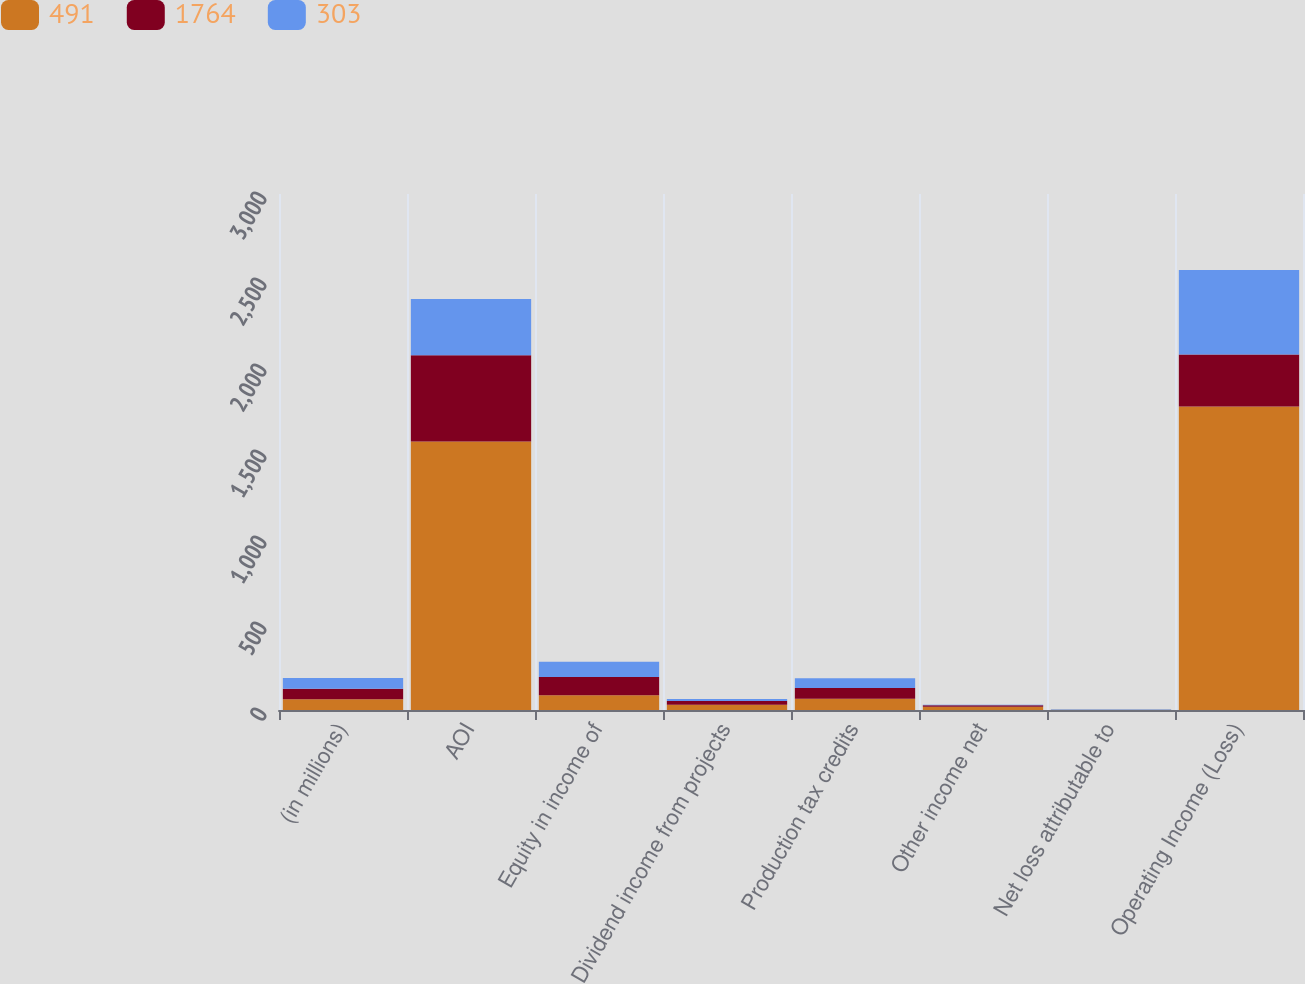<chart> <loc_0><loc_0><loc_500><loc_500><stacked_bar_chart><ecel><fcel>(in millions)<fcel>AOI<fcel>Equity in income of<fcel>Dividend income from projects<fcel>Production tax credits<fcel>Other income net<fcel>Net loss attributable to<fcel>Operating Income (Loss)<nl><fcel>491<fcel>62<fcel>1561<fcel>86<fcel>31<fcel>66<fcel>19<fcel>1<fcel>1764<nl><fcel>1764<fcel>62<fcel>501<fcel>106<fcel>21<fcel>62<fcel>8<fcel>1<fcel>303<nl><fcel>303<fcel>62<fcel>328<fcel>89<fcel>12<fcel>56<fcel>3<fcel>3<fcel>491<nl></chart> 